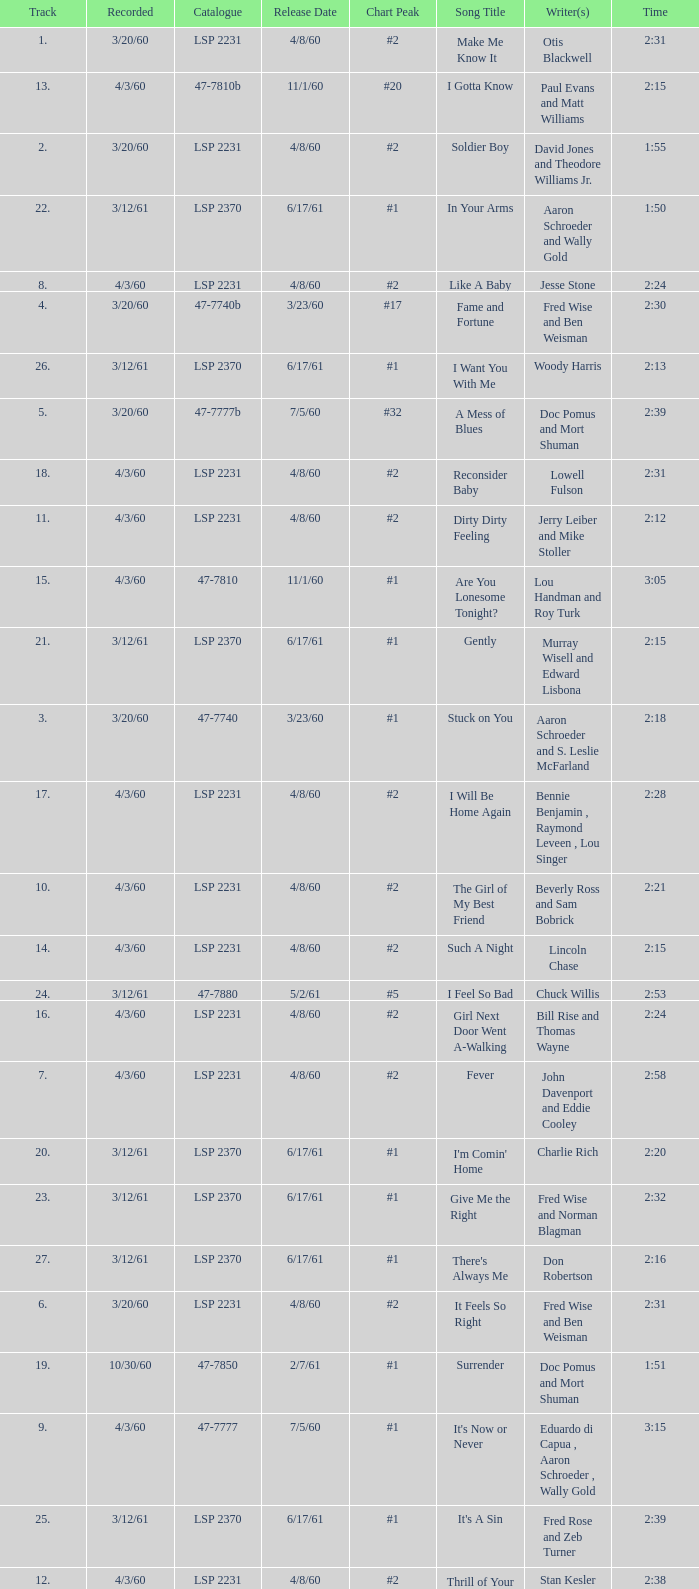What is the time of songs that have the writer Aaron Schroeder and Wally Gold? 1:50. 